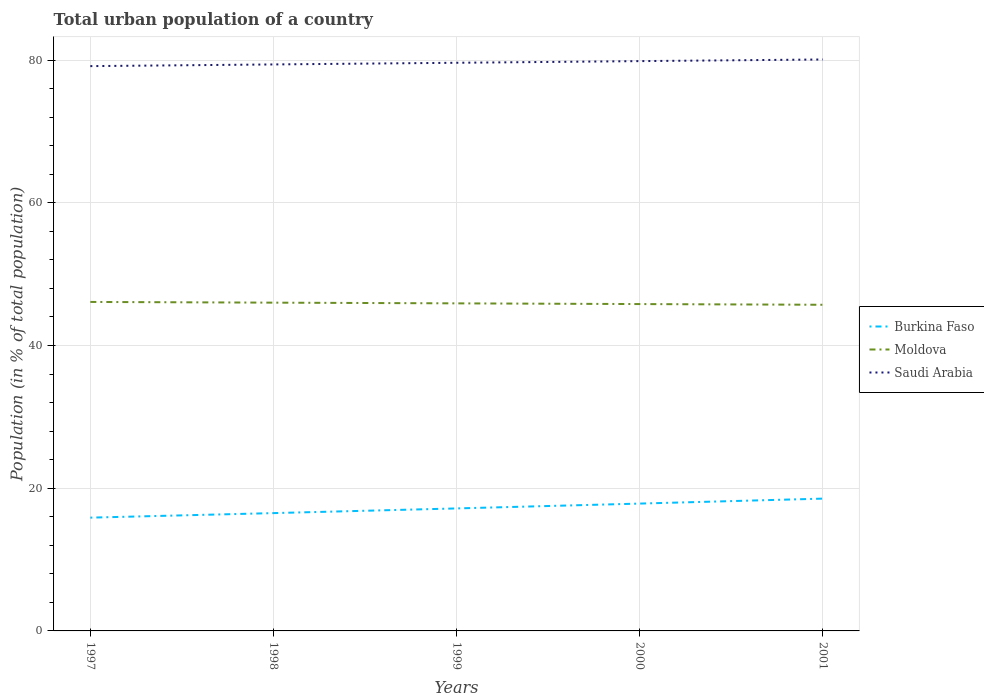How many different coloured lines are there?
Give a very brief answer. 3. Does the line corresponding to Saudi Arabia intersect with the line corresponding to Burkina Faso?
Keep it short and to the point. No. Is the number of lines equal to the number of legend labels?
Make the answer very short. Yes. Across all years, what is the maximum urban population in Burkina Faso?
Ensure brevity in your answer.  15.88. What is the total urban population in Moldova in the graph?
Your response must be concise. 0.1. What is the difference between the highest and the second highest urban population in Burkina Faso?
Offer a very short reply. 2.66. What is the difference between the highest and the lowest urban population in Burkina Faso?
Make the answer very short. 2. Is the urban population in Moldova strictly greater than the urban population in Saudi Arabia over the years?
Give a very brief answer. Yes. How many years are there in the graph?
Provide a short and direct response. 5. What is the difference between two consecutive major ticks on the Y-axis?
Give a very brief answer. 20. Does the graph contain grids?
Provide a short and direct response. Yes. Where does the legend appear in the graph?
Make the answer very short. Center right. What is the title of the graph?
Offer a very short reply. Total urban population of a country. Does "Haiti" appear as one of the legend labels in the graph?
Your answer should be compact. No. What is the label or title of the Y-axis?
Ensure brevity in your answer.  Population (in % of total population). What is the Population (in % of total population) in Burkina Faso in 1997?
Your answer should be compact. 15.88. What is the Population (in % of total population) in Moldova in 1997?
Give a very brief answer. 46.1. What is the Population (in % of total population) in Saudi Arabia in 1997?
Provide a short and direct response. 79.15. What is the Population (in % of total population) in Burkina Faso in 1998?
Keep it short and to the point. 16.51. What is the Population (in % of total population) in Moldova in 1998?
Your response must be concise. 46. What is the Population (in % of total population) in Saudi Arabia in 1998?
Offer a very short reply. 79.38. What is the Population (in % of total population) in Burkina Faso in 1999?
Offer a terse response. 17.17. What is the Population (in % of total population) of Moldova in 1999?
Make the answer very short. 45.9. What is the Population (in % of total population) of Saudi Arabia in 1999?
Ensure brevity in your answer.  79.62. What is the Population (in % of total population) in Burkina Faso in 2000?
Make the answer very short. 17.84. What is the Population (in % of total population) of Moldova in 2000?
Provide a short and direct response. 45.8. What is the Population (in % of total population) of Saudi Arabia in 2000?
Provide a succinct answer. 79.85. What is the Population (in % of total population) in Burkina Faso in 2001?
Your answer should be very brief. 18.54. What is the Population (in % of total population) in Moldova in 2001?
Offer a terse response. 45.7. What is the Population (in % of total population) of Saudi Arabia in 2001?
Give a very brief answer. 80.08. Across all years, what is the maximum Population (in % of total population) in Burkina Faso?
Provide a short and direct response. 18.54. Across all years, what is the maximum Population (in % of total population) in Moldova?
Give a very brief answer. 46.1. Across all years, what is the maximum Population (in % of total population) of Saudi Arabia?
Make the answer very short. 80.08. Across all years, what is the minimum Population (in % of total population) in Burkina Faso?
Offer a very short reply. 15.88. Across all years, what is the minimum Population (in % of total population) in Moldova?
Offer a very short reply. 45.7. Across all years, what is the minimum Population (in % of total population) of Saudi Arabia?
Provide a succinct answer. 79.15. What is the total Population (in % of total population) in Burkina Faso in the graph?
Your response must be concise. 85.94. What is the total Population (in % of total population) in Moldova in the graph?
Your answer should be compact. 229.51. What is the total Population (in % of total population) in Saudi Arabia in the graph?
Give a very brief answer. 398.07. What is the difference between the Population (in % of total population) of Burkina Faso in 1997 and that in 1998?
Your answer should be compact. -0.64. What is the difference between the Population (in % of total population) in Moldova in 1997 and that in 1998?
Give a very brief answer. 0.1. What is the difference between the Population (in % of total population) of Saudi Arabia in 1997 and that in 1998?
Provide a succinct answer. -0.24. What is the difference between the Population (in % of total population) in Burkina Faso in 1997 and that in 1999?
Your answer should be very brief. -1.29. What is the difference between the Population (in % of total population) of Moldova in 1997 and that in 1999?
Your answer should be very brief. 0.2. What is the difference between the Population (in % of total population) in Saudi Arabia in 1997 and that in 1999?
Keep it short and to the point. -0.47. What is the difference between the Population (in % of total population) in Burkina Faso in 1997 and that in 2000?
Provide a succinct answer. -1.97. What is the difference between the Population (in % of total population) in Moldova in 1997 and that in 2000?
Your answer should be very brief. 0.3. What is the difference between the Population (in % of total population) of Saudi Arabia in 1997 and that in 2000?
Offer a very short reply. -0.7. What is the difference between the Population (in % of total population) in Burkina Faso in 1997 and that in 2001?
Your answer should be compact. -2.67. What is the difference between the Population (in % of total population) in Moldova in 1997 and that in 2001?
Offer a very short reply. 0.4. What is the difference between the Population (in % of total population) in Saudi Arabia in 1997 and that in 2001?
Ensure brevity in your answer.  -0.93. What is the difference between the Population (in % of total population) in Burkina Faso in 1998 and that in 1999?
Offer a terse response. -0.66. What is the difference between the Population (in % of total population) of Moldova in 1998 and that in 1999?
Offer a very short reply. 0.1. What is the difference between the Population (in % of total population) in Saudi Arabia in 1998 and that in 1999?
Your answer should be very brief. -0.23. What is the difference between the Population (in % of total population) of Burkina Faso in 1998 and that in 2000?
Ensure brevity in your answer.  -1.33. What is the difference between the Population (in % of total population) of Moldova in 1998 and that in 2000?
Your response must be concise. 0.2. What is the difference between the Population (in % of total population) in Saudi Arabia in 1998 and that in 2000?
Provide a succinct answer. -0.47. What is the difference between the Population (in % of total population) of Burkina Faso in 1998 and that in 2001?
Keep it short and to the point. -2.03. What is the difference between the Population (in % of total population) of Moldova in 1998 and that in 2001?
Your answer should be compact. 0.3. What is the difference between the Population (in % of total population) of Saudi Arabia in 1998 and that in 2001?
Keep it short and to the point. -0.69. What is the difference between the Population (in % of total population) of Burkina Faso in 1999 and that in 2000?
Make the answer very short. -0.68. What is the difference between the Population (in % of total population) of Moldova in 1999 and that in 2000?
Provide a succinct answer. 0.1. What is the difference between the Population (in % of total population) of Saudi Arabia in 1999 and that in 2000?
Your response must be concise. -0.23. What is the difference between the Population (in % of total population) of Burkina Faso in 1999 and that in 2001?
Your answer should be compact. -1.37. What is the difference between the Population (in % of total population) in Moldova in 1999 and that in 2001?
Make the answer very short. 0.2. What is the difference between the Population (in % of total population) of Saudi Arabia in 1999 and that in 2001?
Your answer should be very brief. -0.46. What is the difference between the Population (in % of total population) in Burkina Faso in 2000 and that in 2001?
Your answer should be compact. -0.7. What is the difference between the Population (in % of total population) in Moldova in 2000 and that in 2001?
Your answer should be compact. 0.1. What is the difference between the Population (in % of total population) in Saudi Arabia in 2000 and that in 2001?
Your response must be concise. -0.23. What is the difference between the Population (in % of total population) of Burkina Faso in 1997 and the Population (in % of total population) of Moldova in 1998?
Make the answer very short. -30.13. What is the difference between the Population (in % of total population) of Burkina Faso in 1997 and the Population (in % of total population) of Saudi Arabia in 1998?
Your answer should be very brief. -63.51. What is the difference between the Population (in % of total population) in Moldova in 1997 and the Population (in % of total population) in Saudi Arabia in 1998?
Your response must be concise. -33.28. What is the difference between the Population (in % of total population) in Burkina Faso in 1997 and the Population (in % of total population) in Moldova in 1999?
Give a very brief answer. -30.03. What is the difference between the Population (in % of total population) of Burkina Faso in 1997 and the Population (in % of total population) of Saudi Arabia in 1999?
Give a very brief answer. -63.74. What is the difference between the Population (in % of total population) in Moldova in 1997 and the Population (in % of total population) in Saudi Arabia in 1999?
Your answer should be very brief. -33.52. What is the difference between the Population (in % of total population) of Burkina Faso in 1997 and the Population (in % of total population) of Moldova in 2000?
Give a very brief answer. -29.93. What is the difference between the Population (in % of total population) of Burkina Faso in 1997 and the Population (in % of total population) of Saudi Arabia in 2000?
Ensure brevity in your answer.  -63.97. What is the difference between the Population (in % of total population) of Moldova in 1997 and the Population (in % of total population) of Saudi Arabia in 2000?
Ensure brevity in your answer.  -33.75. What is the difference between the Population (in % of total population) of Burkina Faso in 1997 and the Population (in % of total population) of Moldova in 2001?
Provide a short and direct response. -29.83. What is the difference between the Population (in % of total population) of Burkina Faso in 1997 and the Population (in % of total population) of Saudi Arabia in 2001?
Give a very brief answer. -64.2. What is the difference between the Population (in % of total population) in Moldova in 1997 and the Population (in % of total population) in Saudi Arabia in 2001?
Your answer should be very brief. -33.98. What is the difference between the Population (in % of total population) of Burkina Faso in 1998 and the Population (in % of total population) of Moldova in 1999?
Offer a terse response. -29.39. What is the difference between the Population (in % of total population) in Burkina Faso in 1998 and the Population (in % of total population) in Saudi Arabia in 1999?
Ensure brevity in your answer.  -63.11. What is the difference between the Population (in % of total population) in Moldova in 1998 and the Population (in % of total population) in Saudi Arabia in 1999?
Your answer should be compact. -33.61. What is the difference between the Population (in % of total population) in Burkina Faso in 1998 and the Population (in % of total population) in Moldova in 2000?
Give a very brief answer. -29.29. What is the difference between the Population (in % of total population) in Burkina Faso in 1998 and the Population (in % of total population) in Saudi Arabia in 2000?
Offer a very short reply. -63.34. What is the difference between the Population (in % of total population) in Moldova in 1998 and the Population (in % of total population) in Saudi Arabia in 2000?
Make the answer very short. -33.85. What is the difference between the Population (in % of total population) of Burkina Faso in 1998 and the Population (in % of total population) of Moldova in 2001?
Keep it short and to the point. -29.19. What is the difference between the Population (in % of total population) of Burkina Faso in 1998 and the Population (in % of total population) of Saudi Arabia in 2001?
Your response must be concise. -63.57. What is the difference between the Population (in % of total population) of Moldova in 1998 and the Population (in % of total population) of Saudi Arabia in 2001?
Offer a terse response. -34.08. What is the difference between the Population (in % of total population) of Burkina Faso in 1999 and the Population (in % of total population) of Moldova in 2000?
Your answer should be compact. -28.64. What is the difference between the Population (in % of total population) in Burkina Faso in 1999 and the Population (in % of total population) in Saudi Arabia in 2000?
Your answer should be very brief. -62.68. What is the difference between the Population (in % of total population) of Moldova in 1999 and the Population (in % of total population) of Saudi Arabia in 2000?
Make the answer very short. -33.95. What is the difference between the Population (in % of total population) of Burkina Faso in 1999 and the Population (in % of total population) of Moldova in 2001?
Keep it short and to the point. -28.54. What is the difference between the Population (in % of total population) of Burkina Faso in 1999 and the Population (in % of total population) of Saudi Arabia in 2001?
Your answer should be very brief. -62.91. What is the difference between the Population (in % of total population) in Moldova in 1999 and the Population (in % of total population) in Saudi Arabia in 2001?
Give a very brief answer. -34.17. What is the difference between the Population (in % of total population) of Burkina Faso in 2000 and the Population (in % of total population) of Moldova in 2001?
Your response must be concise. -27.86. What is the difference between the Population (in % of total population) in Burkina Faso in 2000 and the Population (in % of total population) in Saudi Arabia in 2001?
Give a very brief answer. -62.23. What is the difference between the Population (in % of total population) in Moldova in 2000 and the Population (in % of total population) in Saudi Arabia in 2001?
Offer a terse response. -34.27. What is the average Population (in % of total population) in Burkina Faso per year?
Provide a succinct answer. 17.19. What is the average Population (in % of total population) of Moldova per year?
Provide a short and direct response. 45.9. What is the average Population (in % of total population) in Saudi Arabia per year?
Your answer should be compact. 79.61. In the year 1997, what is the difference between the Population (in % of total population) of Burkina Faso and Population (in % of total population) of Moldova?
Give a very brief answer. -30.23. In the year 1997, what is the difference between the Population (in % of total population) of Burkina Faso and Population (in % of total population) of Saudi Arabia?
Keep it short and to the point. -63.27. In the year 1997, what is the difference between the Population (in % of total population) of Moldova and Population (in % of total population) of Saudi Arabia?
Provide a succinct answer. -33.05. In the year 1998, what is the difference between the Population (in % of total population) of Burkina Faso and Population (in % of total population) of Moldova?
Offer a terse response. -29.49. In the year 1998, what is the difference between the Population (in % of total population) of Burkina Faso and Population (in % of total population) of Saudi Arabia?
Ensure brevity in your answer.  -62.87. In the year 1998, what is the difference between the Population (in % of total population) in Moldova and Population (in % of total population) in Saudi Arabia?
Offer a very short reply. -33.38. In the year 1999, what is the difference between the Population (in % of total population) of Burkina Faso and Population (in % of total population) of Moldova?
Provide a succinct answer. -28.74. In the year 1999, what is the difference between the Population (in % of total population) in Burkina Faso and Population (in % of total population) in Saudi Arabia?
Your answer should be very brief. -62.45. In the year 1999, what is the difference between the Population (in % of total population) of Moldova and Population (in % of total population) of Saudi Arabia?
Provide a succinct answer. -33.71. In the year 2000, what is the difference between the Population (in % of total population) of Burkina Faso and Population (in % of total population) of Moldova?
Ensure brevity in your answer.  -27.96. In the year 2000, what is the difference between the Population (in % of total population) of Burkina Faso and Population (in % of total population) of Saudi Arabia?
Ensure brevity in your answer.  -62. In the year 2000, what is the difference between the Population (in % of total population) in Moldova and Population (in % of total population) in Saudi Arabia?
Offer a very short reply. -34.05. In the year 2001, what is the difference between the Population (in % of total population) of Burkina Faso and Population (in % of total population) of Moldova?
Provide a short and direct response. -27.16. In the year 2001, what is the difference between the Population (in % of total population) of Burkina Faso and Population (in % of total population) of Saudi Arabia?
Your answer should be compact. -61.54. In the year 2001, what is the difference between the Population (in % of total population) of Moldova and Population (in % of total population) of Saudi Arabia?
Keep it short and to the point. -34.37. What is the ratio of the Population (in % of total population) of Burkina Faso in 1997 to that in 1998?
Make the answer very short. 0.96. What is the ratio of the Population (in % of total population) of Burkina Faso in 1997 to that in 1999?
Offer a very short reply. 0.92. What is the ratio of the Population (in % of total population) of Saudi Arabia in 1997 to that in 1999?
Make the answer very short. 0.99. What is the ratio of the Population (in % of total population) in Burkina Faso in 1997 to that in 2000?
Your answer should be very brief. 0.89. What is the ratio of the Population (in % of total population) of Burkina Faso in 1997 to that in 2001?
Offer a terse response. 0.86. What is the ratio of the Population (in % of total population) of Moldova in 1997 to that in 2001?
Provide a short and direct response. 1.01. What is the ratio of the Population (in % of total population) in Saudi Arabia in 1997 to that in 2001?
Your response must be concise. 0.99. What is the ratio of the Population (in % of total population) in Burkina Faso in 1998 to that in 1999?
Your response must be concise. 0.96. What is the ratio of the Population (in % of total population) in Moldova in 1998 to that in 1999?
Your answer should be compact. 1. What is the ratio of the Population (in % of total population) in Saudi Arabia in 1998 to that in 1999?
Keep it short and to the point. 1. What is the ratio of the Population (in % of total population) of Burkina Faso in 1998 to that in 2000?
Make the answer very short. 0.93. What is the ratio of the Population (in % of total population) in Burkina Faso in 1998 to that in 2001?
Provide a short and direct response. 0.89. What is the ratio of the Population (in % of total population) of Moldova in 1998 to that in 2001?
Provide a succinct answer. 1.01. What is the ratio of the Population (in % of total population) in Saudi Arabia in 1998 to that in 2001?
Keep it short and to the point. 0.99. What is the ratio of the Population (in % of total population) in Burkina Faso in 1999 to that in 2001?
Provide a short and direct response. 0.93. What is the ratio of the Population (in % of total population) of Moldova in 1999 to that in 2001?
Provide a short and direct response. 1. What is the ratio of the Population (in % of total population) in Burkina Faso in 2000 to that in 2001?
Provide a short and direct response. 0.96. What is the ratio of the Population (in % of total population) in Saudi Arabia in 2000 to that in 2001?
Provide a succinct answer. 1. What is the difference between the highest and the second highest Population (in % of total population) in Burkina Faso?
Provide a short and direct response. 0.7. What is the difference between the highest and the second highest Population (in % of total population) in Moldova?
Make the answer very short. 0.1. What is the difference between the highest and the second highest Population (in % of total population) in Saudi Arabia?
Your response must be concise. 0.23. What is the difference between the highest and the lowest Population (in % of total population) of Burkina Faso?
Your response must be concise. 2.67. What is the difference between the highest and the lowest Population (in % of total population) in Moldova?
Ensure brevity in your answer.  0.4. What is the difference between the highest and the lowest Population (in % of total population) in Saudi Arabia?
Provide a succinct answer. 0.93. 